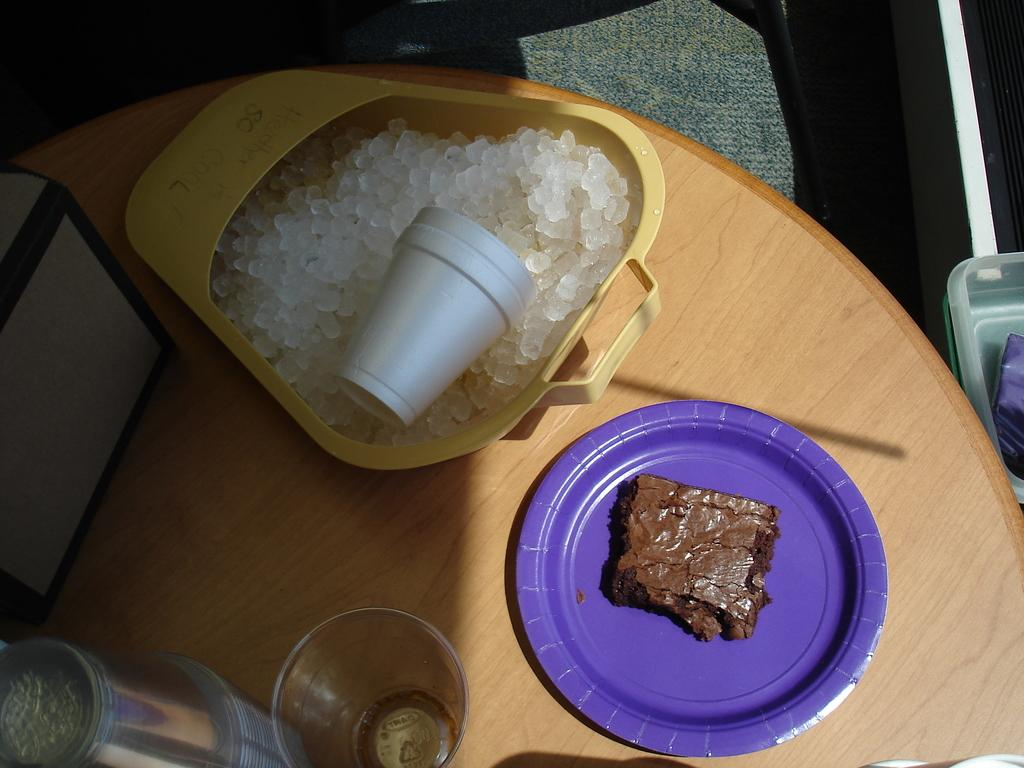What is the main subject of the image? The main subject of the image is food items. How are the food items arranged in the image? The food items are in a plate and also in a yellow object. What else can be seen on the table in the image? There are glasses on the table in the image. How does the tramp contribute to the health of the food items in the image? There is no tramp present in the image, and therefore it cannot contribute to the health of the food items. 